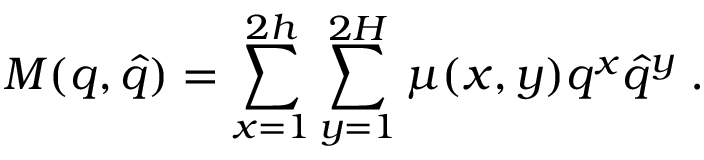Convert formula to latex. <formula><loc_0><loc_0><loc_500><loc_500>M ( q , \hat { q } ) = \sum _ { x = 1 } ^ { 2 h } \sum _ { y = 1 } ^ { 2 H } \mu ( x , y ) q ^ { x } \hat { q } ^ { y } \, .</formula> 